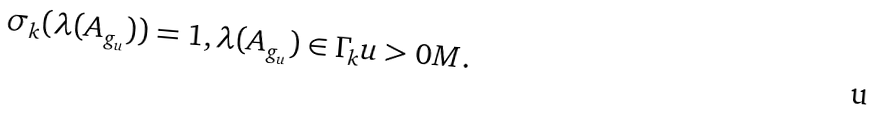<formula> <loc_0><loc_0><loc_500><loc_500>\sigma _ { k } ( \lambda ( A _ { g _ { u } } ) ) = 1 , \lambda ( A _ { g _ { u } } ) \in \Gamma _ { k } u > 0 M .</formula> 